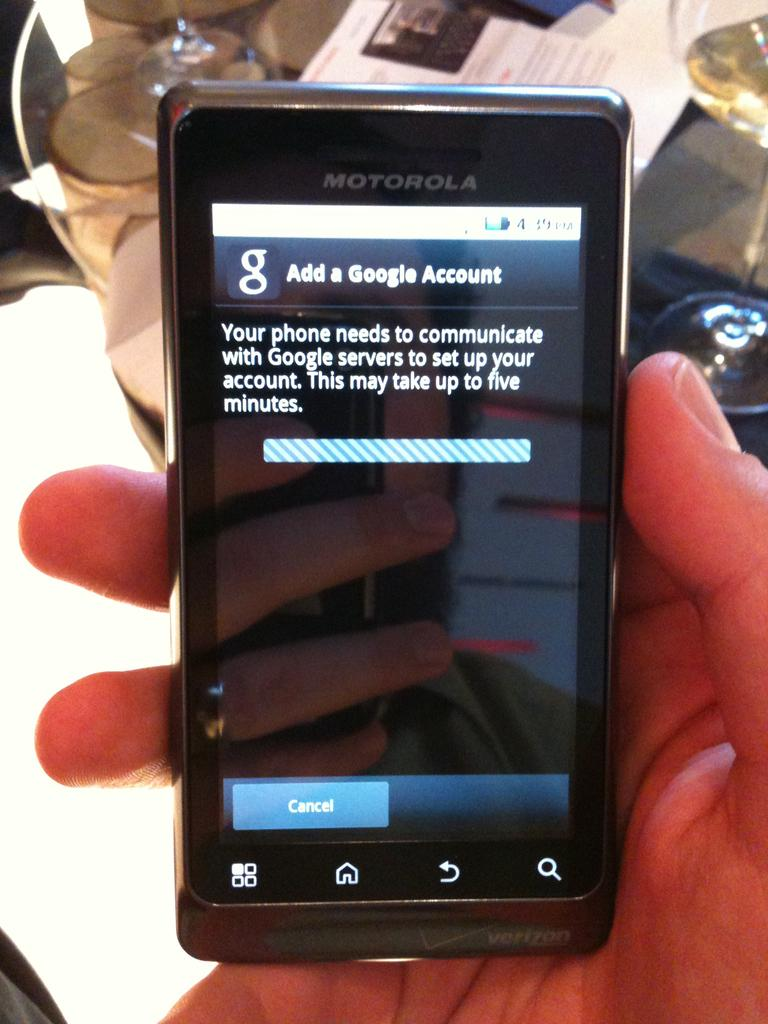<image>
Provide a brief description of the given image. A black Motorola phone with a google page up on its display. 